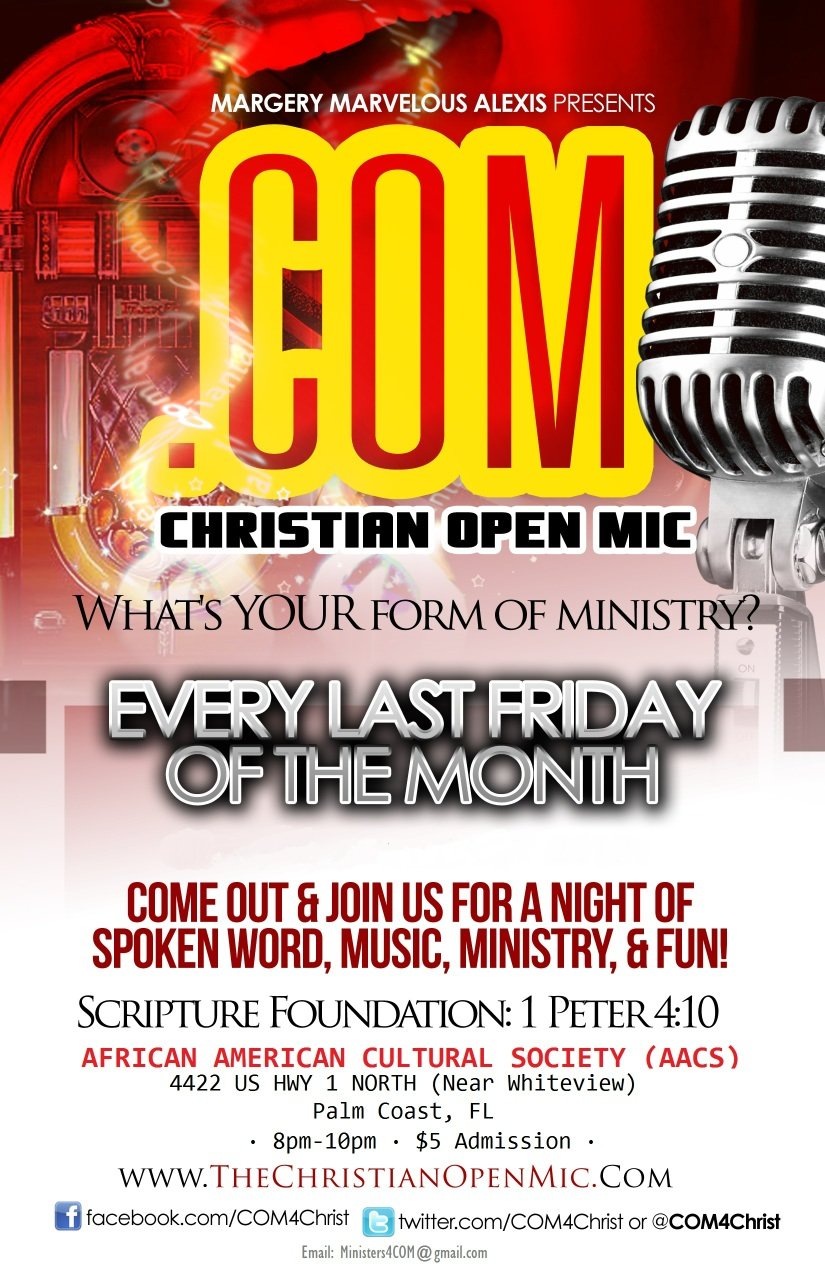Can you describe the cultural significance of the African American Cultural Society? The African American Cultural Society (AACS) in Palm Coast, Florida, holds great cultural significance. It serves as a beacon of African American heritage, promoting the rich history and contributions of African Americans to the wider community. This venue is integral to fostering cultural awareness, education, and unity. Through its various programs and events, the AACS offers an invaluable platform for cultural expression and community engagement. 